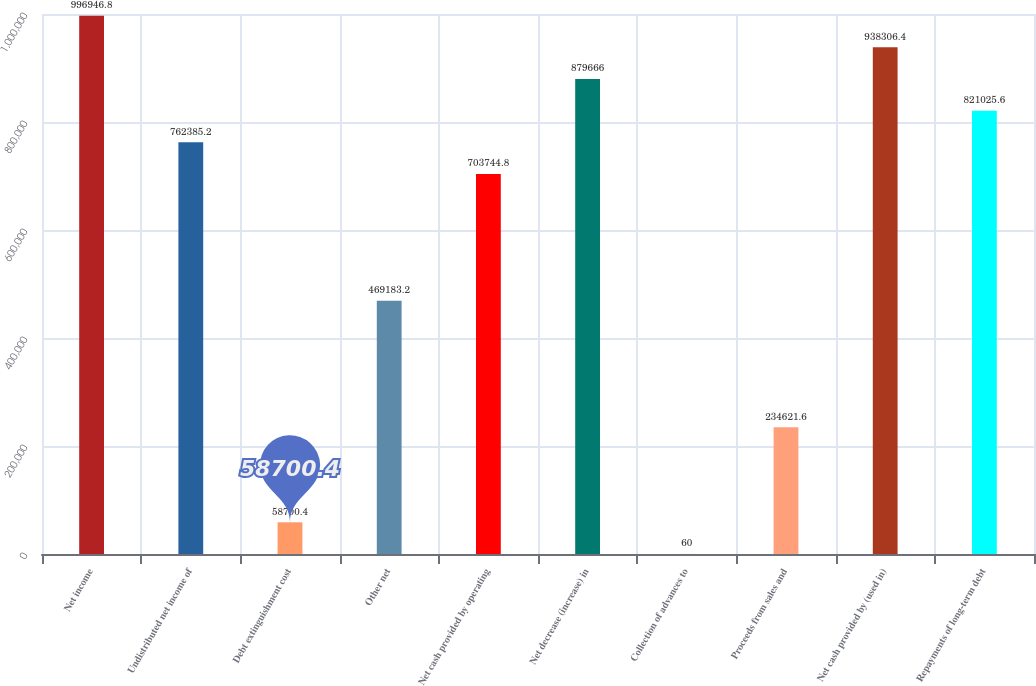<chart> <loc_0><loc_0><loc_500><loc_500><bar_chart><fcel>Net income<fcel>Undistributed net income of<fcel>Debt extinguishment cost<fcel>Other net<fcel>Net cash provided by operating<fcel>Net decrease (increase) in<fcel>Collection of advances to<fcel>Proceeds from sales and<fcel>Net cash provided by (used in)<fcel>Repayments of long-term debt<nl><fcel>996947<fcel>762385<fcel>58700.4<fcel>469183<fcel>703745<fcel>879666<fcel>60<fcel>234622<fcel>938306<fcel>821026<nl></chart> 